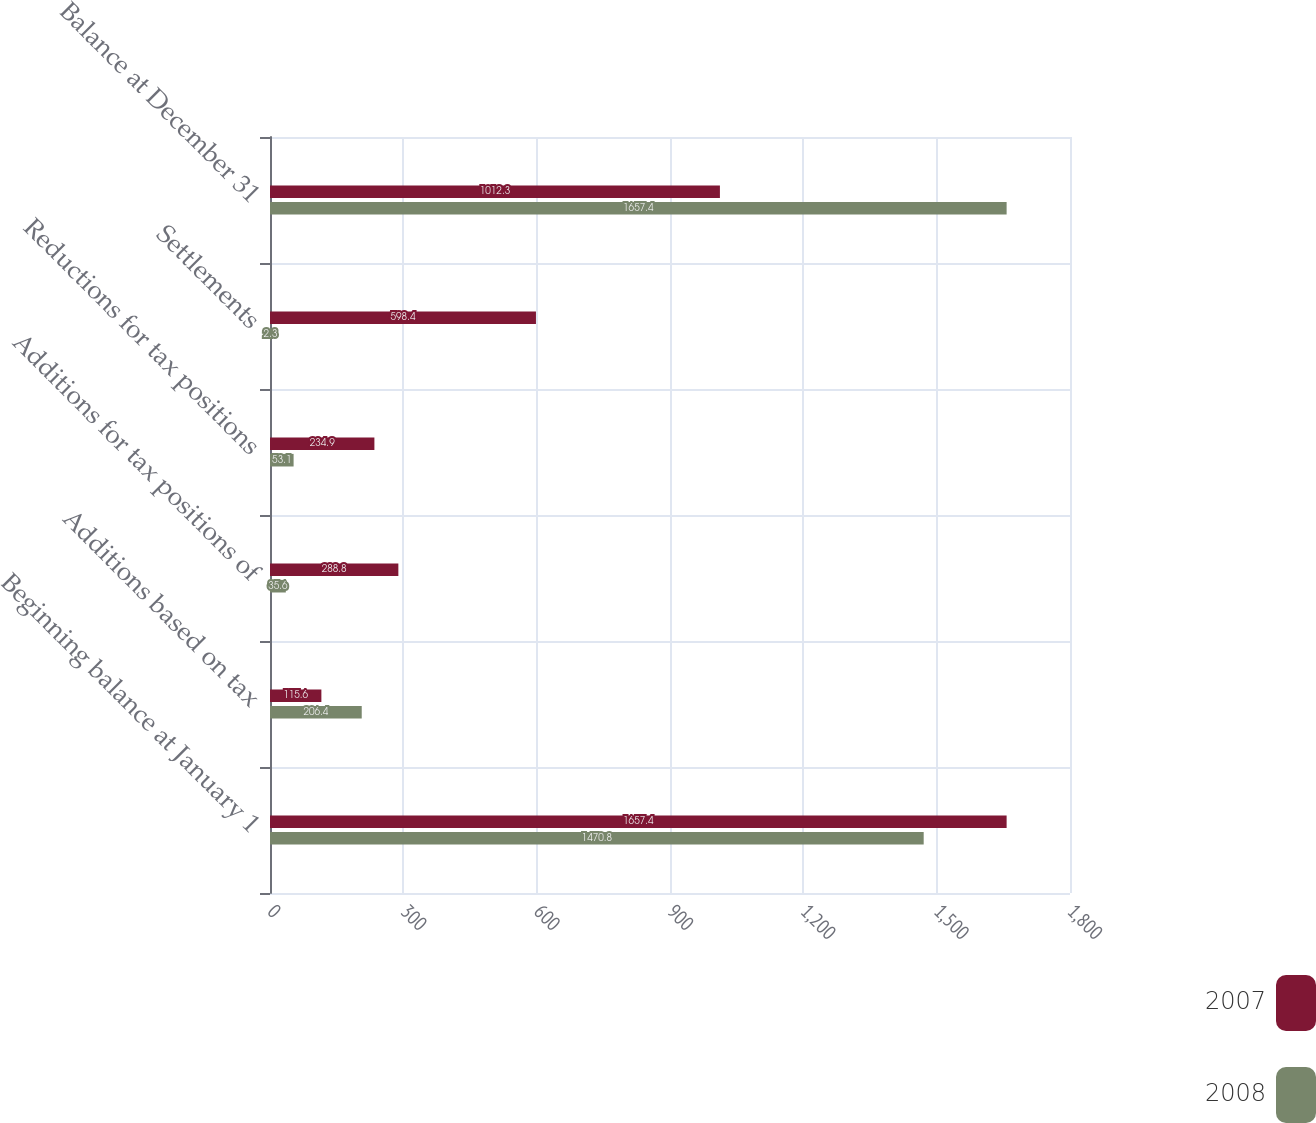<chart> <loc_0><loc_0><loc_500><loc_500><stacked_bar_chart><ecel><fcel>Beginning balance at January 1<fcel>Additions based on tax<fcel>Additions for tax positions of<fcel>Reductions for tax positions<fcel>Settlements<fcel>Balance at December 31<nl><fcel>2007<fcel>1657.4<fcel>115.6<fcel>288.8<fcel>234.9<fcel>598.4<fcel>1012.3<nl><fcel>2008<fcel>1470.8<fcel>206.4<fcel>35.6<fcel>53.1<fcel>2.3<fcel>1657.4<nl></chart> 